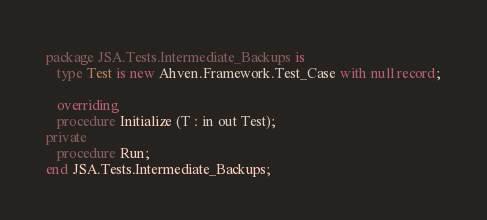<code> <loc_0><loc_0><loc_500><loc_500><_Ada_>
package JSA.Tests.Intermediate_Backups is
   type Test is new Ahven.Framework.Test_Case with null record;

   overriding
   procedure Initialize (T : in out Test);
private
   procedure Run;
end JSA.Tests.Intermediate_Backups;
</code> 